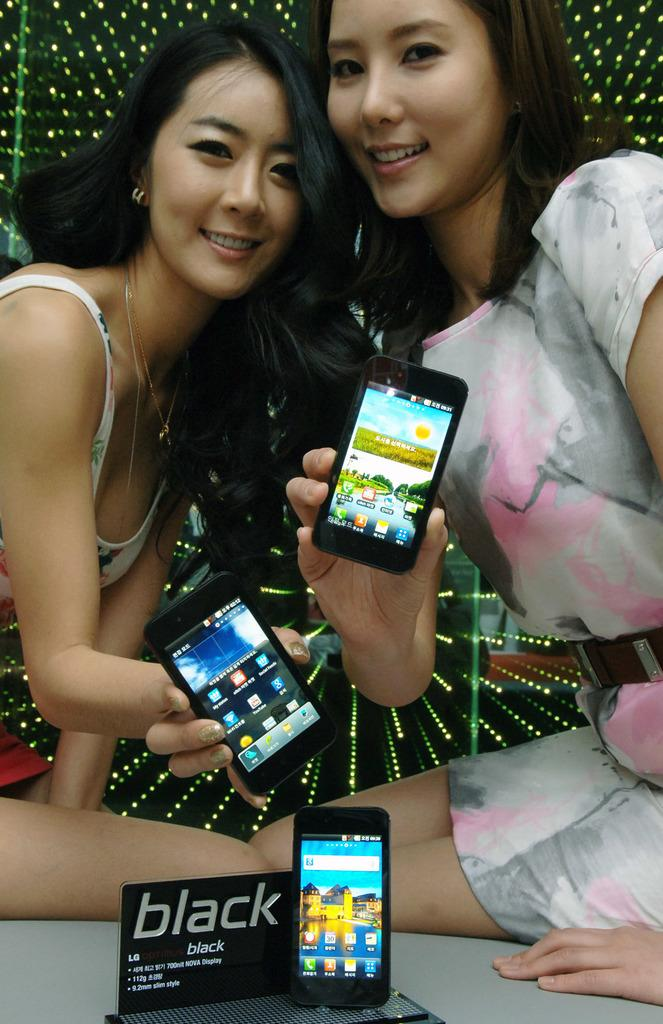<image>
Provide a brief description of the given image. Women holding phones with a sign that says BLACK in front. 